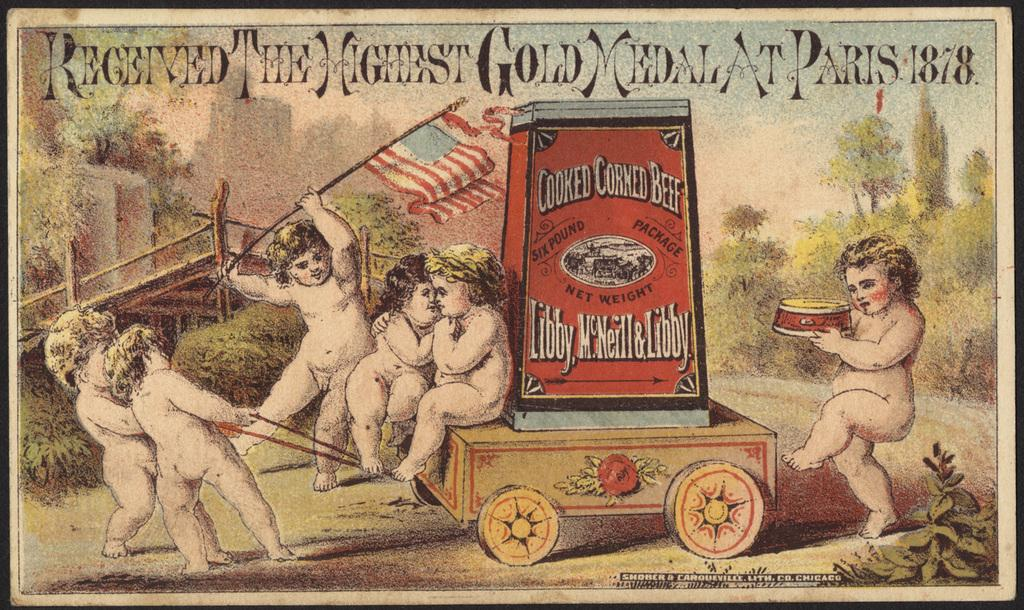<image>
Describe the image concisely. An old art print with six children playing with a Cooked Corned Beef cart. 